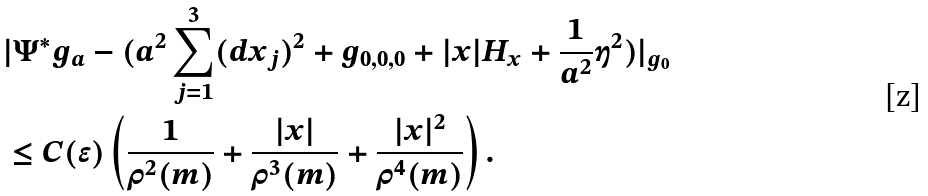Convert formula to latex. <formula><loc_0><loc_0><loc_500><loc_500>& | \Psi ^ { * } g _ { a } - ( a ^ { 2 } \sum _ { j = 1 } ^ { 3 } ( d x _ { j } ) ^ { 2 } + g _ { 0 , 0 , 0 } + | x | H _ { x } + \frac { 1 } { a ^ { 2 } } \eta ^ { 2 } ) | _ { g _ { 0 } } \\ & \leq C ( \epsilon ) \left ( \frac { 1 } { \rho ^ { 2 } ( m ) } + \frac { | x | } { \rho ^ { 3 } ( m ) } + \frac { | x | ^ { 2 } } { \rho ^ { 4 } ( m ) } \right ) .</formula> 